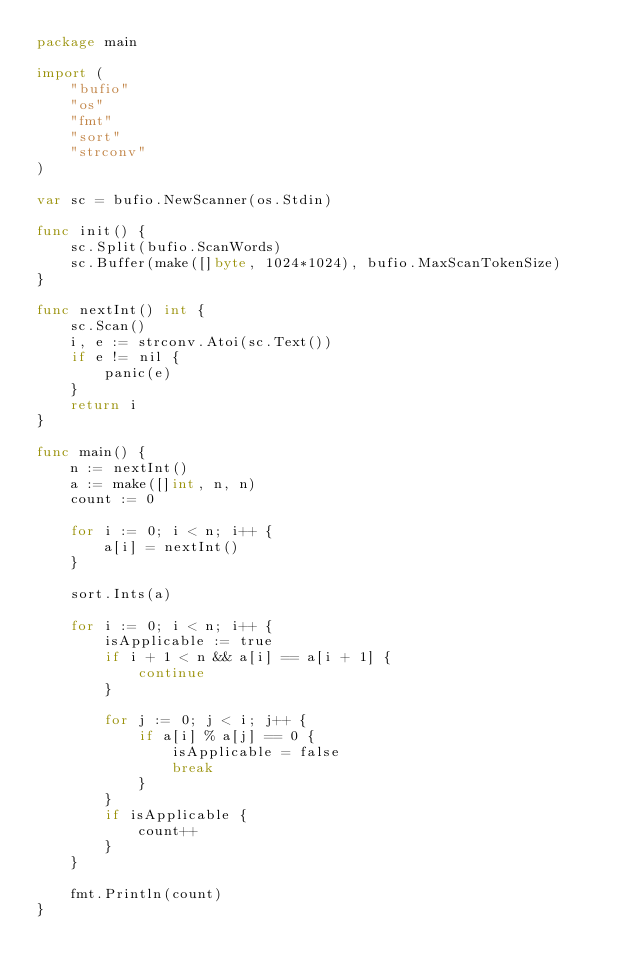Convert code to text. <code><loc_0><loc_0><loc_500><loc_500><_Go_>package main

import (
	"bufio"
	"os"
	"fmt"
	"sort"
	"strconv"
)

var sc = bufio.NewScanner(os.Stdin)

func init() {
	sc.Split(bufio.ScanWords)
	sc.Buffer(make([]byte, 1024*1024), bufio.MaxScanTokenSize)
}

func nextInt() int {
	sc.Scan()
	i, e := strconv.Atoi(sc.Text())
	if e != nil {
		panic(e)
	}
	return i
}

func main() {
	n := nextInt()
	a := make([]int, n, n)
	count := 0

	for i := 0; i < n; i++ {
		a[i] = nextInt()
	}

	sort.Ints(a)

	for i := 0; i < n; i++ {
		isApplicable := true
		if i + 1 < n && a[i] == a[i + 1] {
			continue
		}

		for j := 0; j < i; j++ {
			if a[i] % a[j] == 0 {
				isApplicable = false
				break
			}
		}
		if isApplicable {
			count++
		}
	}

	fmt.Println(count)
}
</code> 